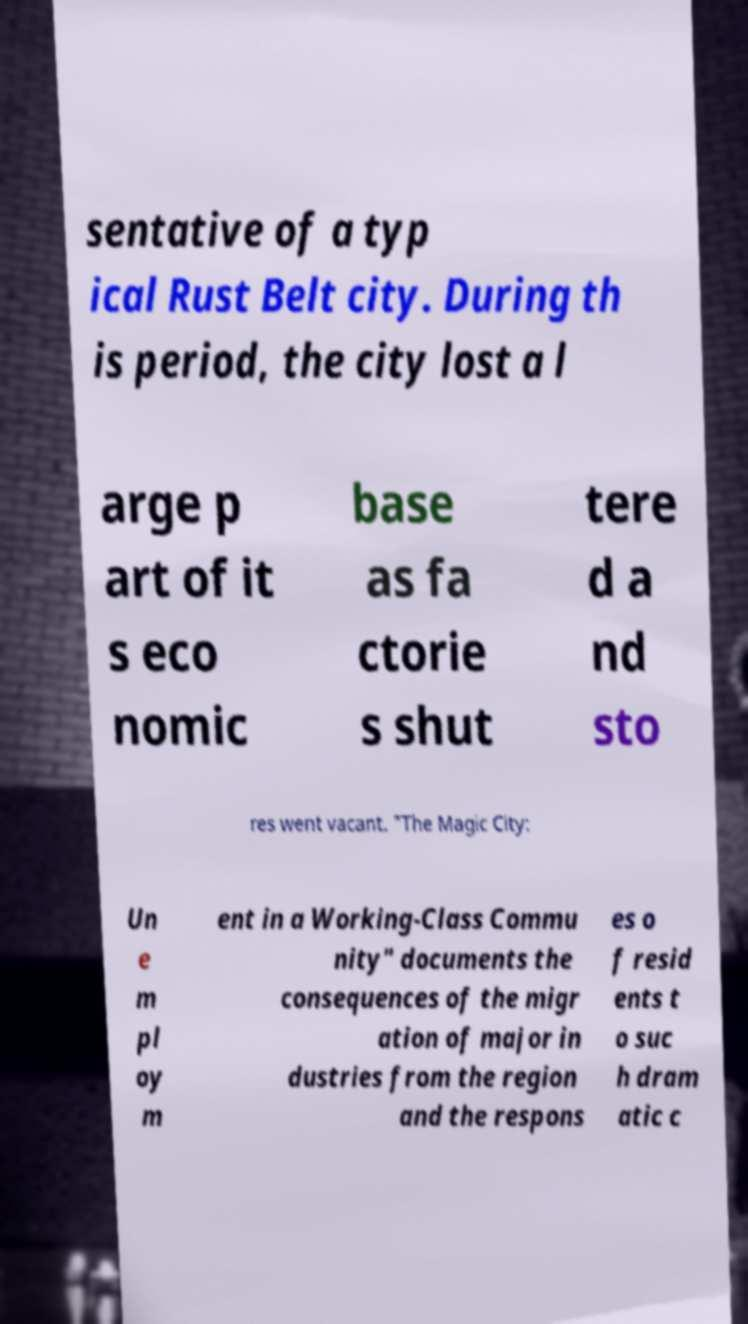There's text embedded in this image that I need extracted. Can you transcribe it verbatim? sentative of a typ ical Rust Belt city. During th is period, the city lost a l arge p art of it s eco nomic base as fa ctorie s shut tere d a nd sto res went vacant. "The Magic City: Un e m pl oy m ent in a Working-Class Commu nity" documents the consequences of the migr ation of major in dustries from the region and the respons es o f resid ents t o suc h dram atic c 